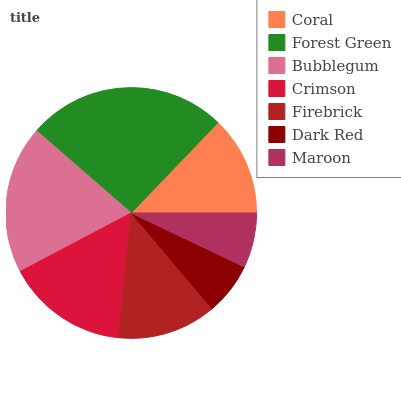Is Dark Red the minimum?
Answer yes or no. Yes. Is Forest Green the maximum?
Answer yes or no. Yes. Is Bubblegum the minimum?
Answer yes or no. No. Is Bubblegum the maximum?
Answer yes or no. No. Is Forest Green greater than Bubblegum?
Answer yes or no. Yes. Is Bubblegum less than Forest Green?
Answer yes or no. Yes. Is Bubblegum greater than Forest Green?
Answer yes or no. No. Is Forest Green less than Bubblegum?
Answer yes or no. No. Is Coral the high median?
Answer yes or no. Yes. Is Coral the low median?
Answer yes or no. Yes. Is Bubblegum the high median?
Answer yes or no. No. Is Crimson the low median?
Answer yes or no. No. 